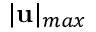Convert formula to latex. <formula><loc_0><loc_0><loc_500><loc_500>| u | _ { \max }</formula> 